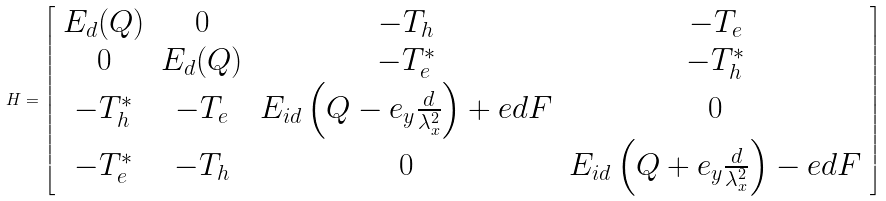Convert formula to latex. <formula><loc_0><loc_0><loc_500><loc_500>H = \left [ \begin{array} { c c c c } E _ { d } ( { Q } ) & 0 & - T _ { h } & - T _ { e } \\ 0 & E _ { d } ( { Q } ) & - T _ { e } ^ { * } & - T _ { h } ^ { * } \\ - T _ { h } ^ { * } & - T _ { e } & E _ { i d } \left ( { Q } - { e } _ { y } \frac { d } { \lambda _ { x } ^ { 2 } } \right ) + e d F & 0 \\ - T _ { e } ^ { * } & - T _ { h } & 0 & E _ { i d } \left ( { Q } + { e } _ { y } \frac { d } { \lambda _ { x } ^ { 2 } } \right ) - e d F \end{array} \right ]</formula> 